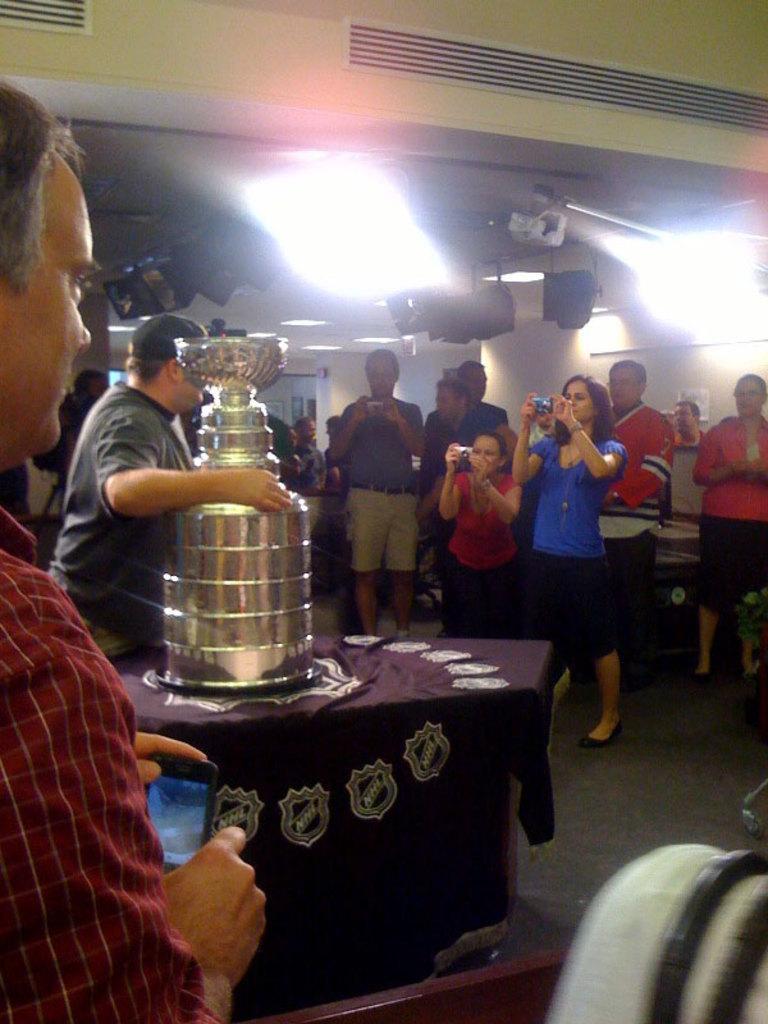Describe this image in one or two sentences. In this image, we can see a group of people. Few people are holding some objects. Here we can see a table covered with cloth. Some container is placed on it. At the bottom of the image, we can see an object. Background there is a wall, few objects, lights and ceiling. 